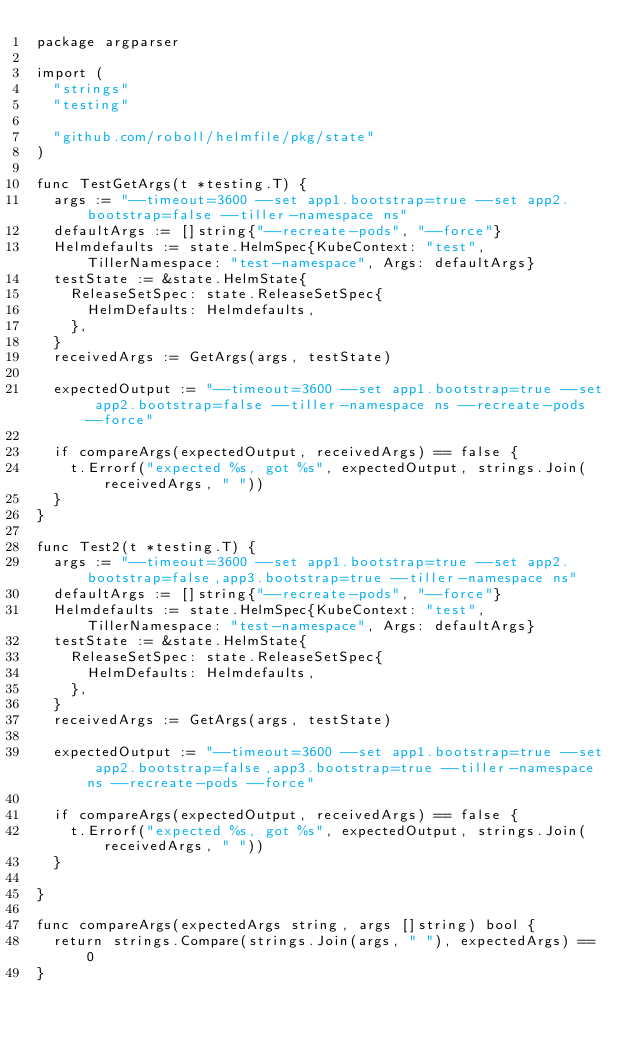Convert code to text. <code><loc_0><loc_0><loc_500><loc_500><_Go_>package argparser

import (
	"strings"
	"testing"

	"github.com/roboll/helmfile/pkg/state"
)

func TestGetArgs(t *testing.T) {
	args := "--timeout=3600 --set app1.bootstrap=true --set app2.bootstrap=false --tiller-namespace ns"
	defaultArgs := []string{"--recreate-pods", "--force"}
	Helmdefaults := state.HelmSpec{KubeContext: "test", TillerNamespace: "test-namespace", Args: defaultArgs}
	testState := &state.HelmState{
		ReleaseSetSpec: state.ReleaseSetSpec{
			HelmDefaults: Helmdefaults,
		},
	}
	receivedArgs := GetArgs(args, testState)

	expectedOutput := "--timeout=3600 --set app1.bootstrap=true --set app2.bootstrap=false --tiller-namespace ns --recreate-pods --force"

	if compareArgs(expectedOutput, receivedArgs) == false {
		t.Errorf("expected %s, got %s", expectedOutput, strings.Join(receivedArgs, " "))
	}
}

func Test2(t *testing.T) {
	args := "--timeout=3600 --set app1.bootstrap=true --set app2.bootstrap=false,app3.bootstrap=true --tiller-namespace ns"
	defaultArgs := []string{"--recreate-pods", "--force"}
	Helmdefaults := state.HelmSpec{KubeContext: "test", TillerNamespace: "test-namespace", Args: defaultArgs}
	testState := &state.HelmState{
		ReleaseSetSpec: state.ReleaseSetSpec{
			HelmDefaults: Helmdefaults,
		},
	}
	receivedArgs := GetArgs(args, testState)

	expectedOutput := "--timeout=3600 --set app1.bootstrap=true --set app2.bootstrap=false,app3.bootstrap=true --tiller-namespace ns --recreate-pods --force"

	if compareArgs(expectedOutput, receivedArgs) == false {
		t.Errorf("expected %s, got %s", expectedOutput, strings.Join(receivedArgs, " "))
	}

}

func compareArgs(expectedArgs string, args []string) bool {
	return strings.Compare(strings.Join(args, " "), expectedArgs) == 0
}
</code> 